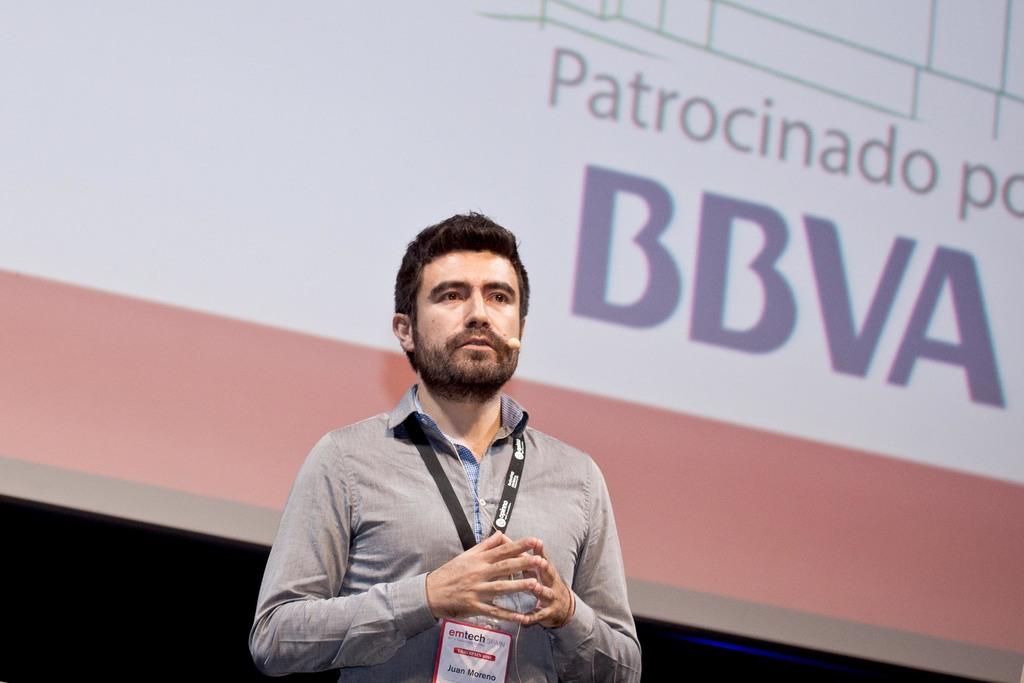What does it say on the monitor?
Give a very brief answer. Patrocinado bbva. Patrocinado po bbva?
Provide a short and direct response. Yes. 